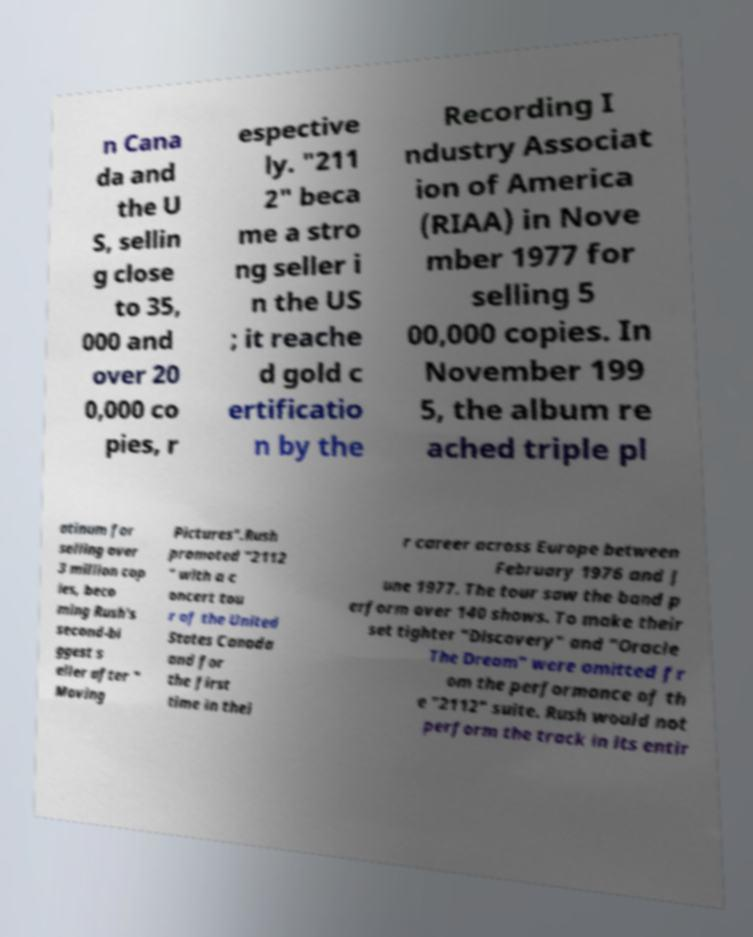Can you accurately transcribe the text from the provided image for me? n Cana da and the U S, sellin g close to 35, 000 and over 20 0,000 co pies, r espective ly. "211 2" beca me a stro ng seller i n the US ; it reache d gold c ertificatio n by the Recording I ndustry Associat ion of America (RIAA) in Nove mber 1977 for selling 5 00,000 copies. In November 199 5, the album re ached triple pl atinum for selling over 3 million cop ies, beco ming Rush's second-bi ggest s eller after " Moving Pictures".Rush promoted "2112 " with a c oncert tou r of the United States Canada and for the first time in thei r career across Europe between February 1976 and J une 1977. The tour saw the band p erform over 140 shows. To make their set tighter "Discovery" and "Oracle The Dream" were omitted fr om the performance of th e "2112" suite. Rush would not perform the track in its entir 